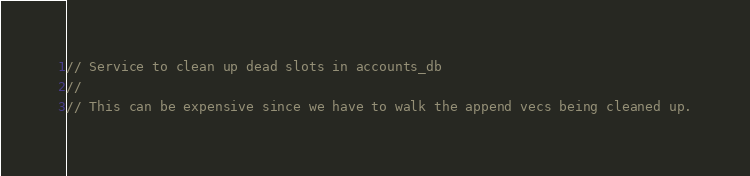<code> <loc_0><loc_0><loc_500><loc_500><_Rust_>// Service to clean up dead slots in accounts_db
//
// This can be expensive since we have to walk the append vecs being cleaned up.
</code> 